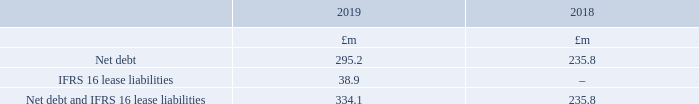Net debt including IFRS 16 lease liabilities
A reconciliation between net debt and net debt including IFRS 16 lease liabilities is given below. A breakdown of the balances that are included within net debt is given within Note 24. Net debt excludes IFRS 16 lease liabilities to enable comparability with prior years.
What does net debt exclude? Ifrs 16 lease liabilities to enable comparability with prior years. Where is the breakdown of the balances that are included within net debt given? Within note 24. What is the Net debt and IFRS 16 lease liabilities for 2018 and 2019 respectively?
Answer scale should be: million. 235.8, 334.1. In which year is the amount of net debt larger? 295.2>235.8
Answer: 2019. What was the change in the amount of Net debt and IFRS 16 lease liabilities from 2018 to 2019?
Answer scale should be: million. 334.1-235.8
Answer: 98.3. What was the percentage change in the amount of Net debt and IFRS 16 lease liabilities from 2018 to 2019?
Answer scale should be: percent. (334.1-235.8)/235.8
Answer: 41.69. 